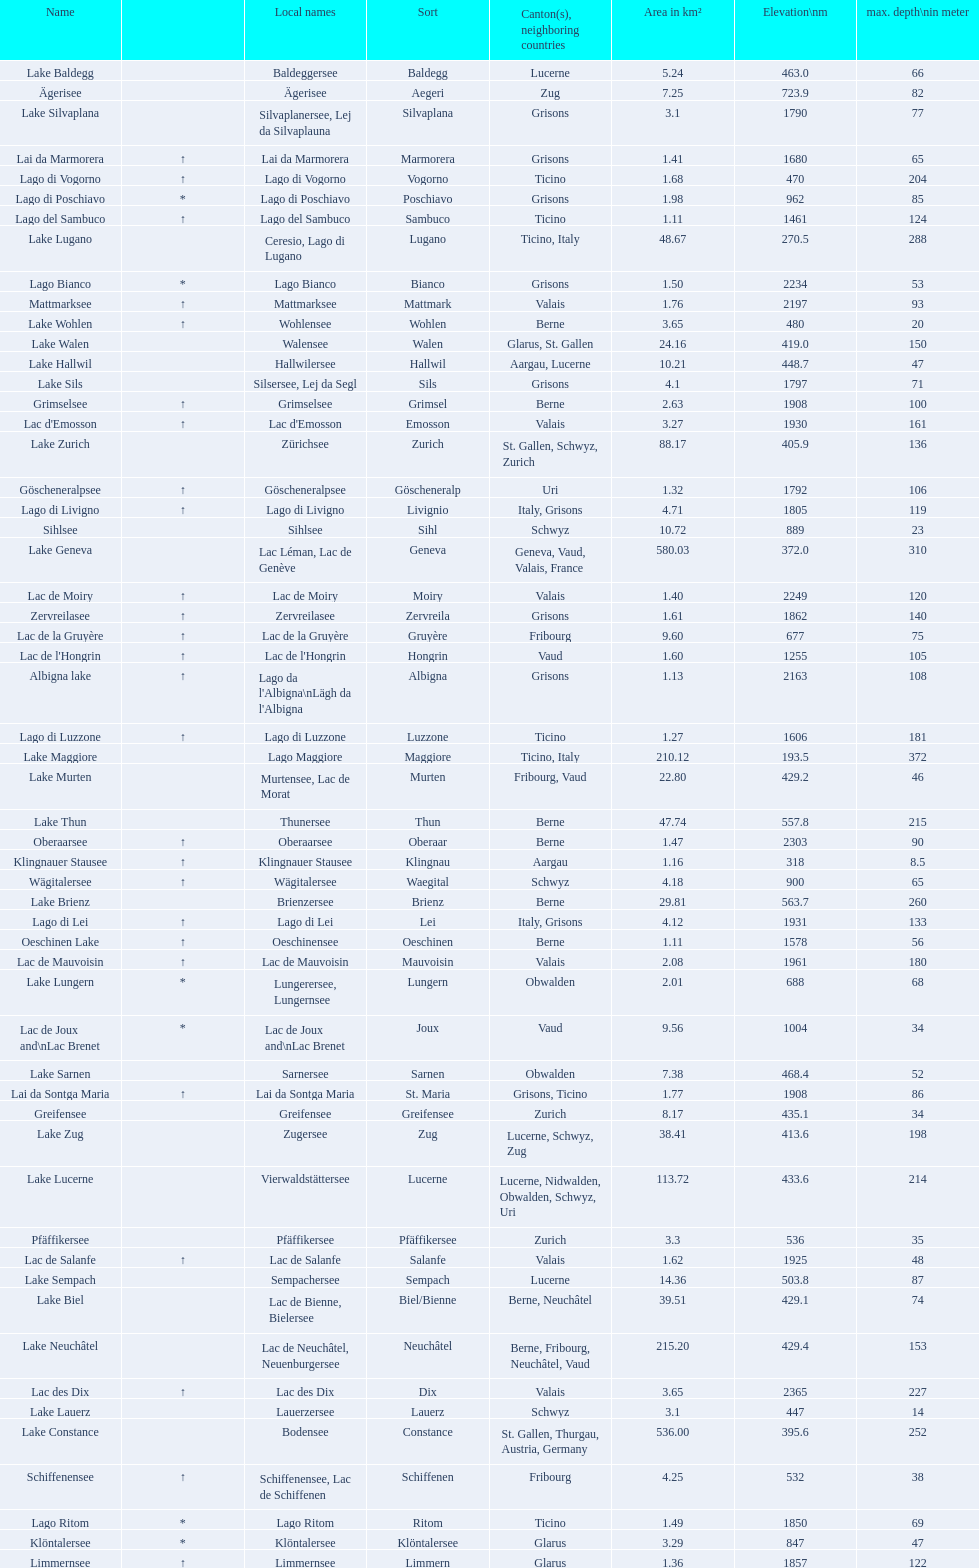Which lake has the largest elevation? Lac des Dix. 